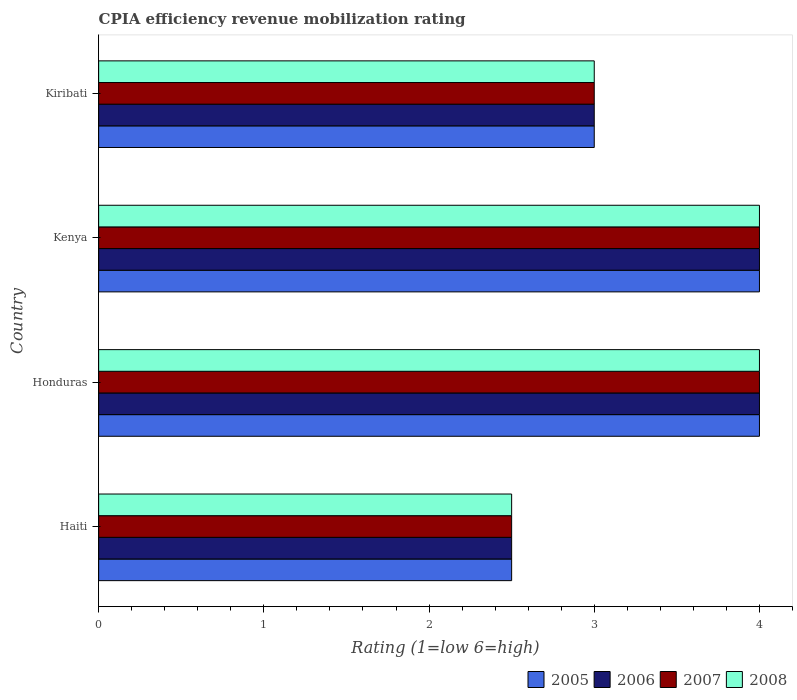How many different coloured bars are there?
Your answer should be compact. 4. Are the number of bars on each tick of the Y-axis equal?
Give a very brief answer. Yes. What is the label of the 1st group of bars from the top?
Provide a succinct answer. Kiribati. What is the CPIA rating in 2005 in Kenya?
Provide a short and direct response. 4. Across all countries, what is the maximum CPIA rating in 2007?
Offer a very short reply. 4. Across all countries, what is the minimum CPIA rating in 2006?
Your answer should be compact. 2.5. In which country was the CPIA rating in 2006 maximum?
Make the answer very short. Honduras. In which country was the CPIA rating in 2005 minimum?
Your response must be concise. Haiti. What is the total CPIA rating in 2007 in the graph?
Offer a very short reply. 13.5. What is the difference between the CPIA rating in 2005 in Haiti and that in Honduras?
Offer a very short reply. -1.5. What is the difference between the CPIA rating in 2008 in Kenya and the CPIA rating in 2005 in Honduras?
Keep it short and to the point. 0. What is the average CPIA rating in 2008 per country?
Make the answer very short. 3.38. What is the difference between the CPIA rating in 2005 and CPIA rating in 2006 in Kiribati?
Keep it short and to the point. 0. In how many countries, is the CPIA rating in 2006 greater than 1.8 ?
Provide a short and direct response. 4. What is the ratio of the CPIA rating in 2006 in Honduras to that in Kiribati?
Offer a very short reply. 1.33. Is the CPIA rating in 2008 in Haiti less than that in Honduras?
Provide a short and direct response. Yes. Is the sum of the CPIA rating in 2007 in Honduras and Kenya greater than the maximum CPIA rating in 2005 across all countries?
Offer a terse response. Yes. Is it the case that in every country, the sum of the CPIA rating in 2005 and CPIA rating in 2007 is greater than the sum of CPIA rating in 2006 and CPIA rating in 2008?
Ensure brevity in your answer.  No. Is it the case that in every country, the sum of the CPIA rating in 2005 and CPIA rating in 2007 is greater than the CPIA rating in 2006?
Make the answer very short. Yes. How many bars are there?
Your response must be concise. 16. How many countries are there in the graph?
Offer a very short reply. 4. Are the values on the major ticks of X-axis written in scientific E-notation?
Your answer should be compact. No. Does the graph contain any zero values?
Your answer should be very brief. No. Does the graph contain grids?
Provide a short and direct response. No. Where does the legend appear in the graph?
Offer a very short reply. Bottom right. How are the legend labels stacked?
Provide a succinct answer. Horizontal. What is the title of the graph?
Your answer should be compact. CPIA efficiency revenue mobilization rating. What is the label or title of the Y-axis?
Ensure brevity in your answer.  Country. What is the Rating (1=low 6=high) of 2005 in Haiti?
Provide a short and direct response. 2.5. What is the Rating (1=low 6=high) in 2006 in Haiti?
Ensure brevity in your answer.  2.5. What is the Rating (1=low 6=high) in 2007 in Haiti?
Your answer should be compact. 2.5. What is the Rating (1=low 6=high) of 2008 in Haiti?
Offer a terse response. 2.5. What is the Rating (1=low 6=high) of 2005 in Honduras?
Ensure brevity in your answer.  4. What is the Rating (1=low 6=high) of 2005 in Kenya?
Your answer should be very brief. 4. What is the Rating (1=low 6=high) in 2006 in Kiribati?
Your answer should be compact. 3. What is the Rating (1=low 6=high) in 2007 in Kiribati?
Give a very brief answer. 3. What is the Rating (1=low 6=high) in 2008 in Kiribati?
Give a very brief answer. 3. Across all countries, what is the maximum Rating (1=low 6=high) in 2006?
Keep it short and to the point. 4. Across all countries, what is the maximum Rating (1=low 6=high) of 2008?
Provide a succinct answer. 4. Across all countries, what is the minimum Rating (1=low 6=high) in 2006?
Keep it short and to the point. 2.5. Across all countries, what is the minimum Rating (1=low 6=high) in 2007?
Offer a terse response. 2.5. What is the total Rating (1=low 6=high) of 2005 in the graph?
Your response must be concise. 13.5. What is the total Rating (1=low 6=high) of 2008 in the graph?
Your answer should be very brief. 13.5. What is the difference between the Rating (1=low 6=high) of 2006 in Haiti and that in Honduras?
Make the answer very short. -1.5. What is the difference between the Rating (1=low 6=high) in 2005 in Haiti and that in Kenya?
Your response must be concise. -1.5. What is the difference between the Rating (1=low 6=high) in 2006 in Haiti and that in Kenya?
Offer a terse response. -1.5. What is the difference between the Rating (1=low 6=high) of 2007 in Haiti and that in Kenya?
Your answer should be compact. -1.5. What is the difference between the Rating (1=low 6=high) of 2005 in Honduras and that in Kiribati?
Provide a short and direct response. 1. What is the difference between the Rating (1=low 6=high) in 2006 in Honduras and that in Kiribati?
Offer a very short reply. 1. What is the difference between the Rating (1=low 6=high) of 2007 in Honduras and that in Kiribati?
Make the answer very short. 1. What is the difference between the Rating (1=low 6=high) of 2005 in Kenya and that in Kiribati?
Offer a very short reply. 1. What is the difference between the Rating (1=low 6=high) of 2006 in Haiti and the Rating (1=low 6=high) of 2007 in Honduras?
Offer a very short reply. -1.5. What is the difference between the Rating (1=low 6=high) of 2006 in Haiti and the Rating (1=low 6=high) of 2008 in Honduras?
Your response must be concise. -1.5. What is the difference between the Rating (1=low 6=high) in 2007 in Haiti and the Rating (1=low 6=high) in 2008 in Honduras?
Provide a short and direct response. -1.5. What is the difference between the Rating (1=low 6=high) of 2005 in Haiti and the Rating (1=low 6=high) of 2006 in Kenya?
Offer a very short reply. -1.5. What is the difference between the Rating (1=low 6=high) of 2005 in Haiti and the Rating (1=low 6=high) of 2007 in Kenya?
Your answer should be very brief. -1.5. What is the difference between the Rating (1=low 6=high) of 2006 in Haiti and the Rating (1=low 6=high) of 2007 in Kenya?
Your answer should be very brief. -1.5. What is the difference between the Rating (1=low 6=high) in 2005 in Haiti and the Rating (1=low 6=high) in 2006 in Kiribati?
Provide a succinct answer. -0.5. What is the difference between the Rating (1=low 6=high) of 2006 in Haiti and the Rating (1=low 6=high) of 2007 in Kiribati?
Your response must be concise. -0.5. What is the difference between the Rating (1=low 6=high) of 2005 in Honduras and the Rating (1=low 6=high) of 2006 in Kenya?
Provide a succinct answer. 0. What is the difference between the Rating (1=low 6=high) in 2007 in Honduras and the Rating (1=low 6=high) in 2008 in Kenya?
Provide a short and direct response. 0. What is the difference between the Rating (1=low 6=high) in 2005 in Honduras and the Rating (1=low 6=high) in 2006 in Kiribati?
Provide a short and direct response. 1. What is the difference between the Rating (1=low 6=high) in 2005 in Honduras and the Rating (1=low 6=high) in 2007 in Kiribati?
Your response must be concise. 1. What is the difference between the Rating (1=low 6=high) in 2006 in Honduras and the Rating (1=low 6=high) in 2007 in Kiribati?
Provide a short and direct response. 1. What is the difference between the Rating (1=low 6=high) of 2005 in Kenya and the Rating (1=low 6=high) of 2006 in Kiribati?
Ensure brevity in your answer.  1. What is the difference between the Rating (1=low 6=high) of 2005 in Kenya and the Rating (1=low 6=high) of 2008 in Kiribati?
Make the answer very short. 1. What is the difference between the Rating (1=low 6=high) in 2006 in Kenya and the Rating (1=low 6=high) in 2008 in Kiribati?
Offer a terse response. 1. What is the difference between the Rating (1=low 6=high) in 2007 in Kenya and the Rating (1=low 6=high) in 2008 in Kiribati?
Offer a terse response. 1. What is the average Rating (1=low 6=high) in 2005 per country?
Give a very brief answer. 3.38. What is the average Rating (1=low 6=high) in 2006 per country?
Keep it short and to the point. 3.38. What is the average Rating (1=low 6=high) in 2007 per country?
Offer a very short reply. 3.38. What is the average Rating (1=low 6=high) of 2008 per country?
Provide a short and direct response. 3.38. What is the difference between the Rating (1=low 6=high) of 2005 and Rating (1=low 6=high) of 2006 in Haiti?
Keep it short and to the point. 0. What is the difference between the Rating (1=low 6=high) in 2005 and Rating (1=low 6=high) in 2007 in Haiti?
Your response must be concise. 0. What is the difference between the Rating (1=low 6=high) in 2006 and Rating (1=low 6=high) in 2008 in Haiti?
Offer a very short reply. 0. What is the difference between the Rating (1=low 6=high) in 2005 and Rating (1=low 6=high) in 2006 in Honduras?
Provide a succinct answer. 0. What is the difference between the Rating (1=low 6=high) of 2005 and Rating (1=low 6=high) of 2007 in Honduras?
Make the answer very short. 0. What is the difference between the Rating (1=low 6=high) in 2005 and Rating (1=low 6=high) in 2006 in Kenya?
Ensure brevity in your answer.  0. What is the difference between the Rating (1=low 6=high) of 2005 and Rating (1=low 6=high) of 2007 in Kenya?
Your answer should be very brief. 0. What is the difference between the Rating (1=low 6=high) in 2005 and Rating (1=low 6=high) in 2008 in Kenya?
Your answer should be very brief. 0. What is the difference between the Rating (1=low 6=high) of 2006 and Rating (1=low 6=high) of 2007 in Kenya?
Provide a succinct answer. 0. What is the difference between the Rating (1=low 6=high) of 2005 and Rating (1=low 6=high) of 2007 in Kiribati?
Ensure brevity in your answer.  0. What is the difference between the Rating (1=low 6=high) of 2006 and Rating (1=low 6=high) of 2007 in Kiribati?
Make the answer very short. 0. What is the difference between the Rating (1=low 6=high) in 2006 and Rating (1=low 6=high) in 2008 in Kiribati?
Your answer should be very brief. 0. What is the difference between the Rating (1=low 6=high) of 2007 and Rating (1=low 6=high) of 2008 in Kiribati?
Your answer should be very brief. 0. What is the ratio of the Rating (1=low 6=high) of 2007 in Haiti to that in Honduras?
Offer a terse response. 0.62. What is the ratio of the Rating (1=low 6=high) in 2008 in Haiti to that in Honduras?
Ensure brevity in your answer.  0.62. What is the ratio of the Rating (1=low 6=high) in 2006 in Haiti to that in Kenya?
Ensure brevity in your answer.  0.62. What is the ratio of the Rating (1=low 6=high) of 2007 in Haiti to that in Kenya?
Provide a short and direct response. 0.62. What is the ratio of the Rating (1=low 6=high) of 2008 in Haiti to that in Kenya?
Your answer should be very brief. 0.62. What is the ratio of the Rating (1=low 6=high) in 2007 in Haiti to that in Kiribati?
Offer a very short reply. 0.83. What is the ratio of the Rating (1=low 6=high) of 2008 in Haiti to that in Kiribati?
Give a very brief answer. 0.83. What is the ratio of the Rating (1=low 6=high) in 2006 in Honduras to that in Kenya?
Ensure brevity in your answer.  1. What is the ratio of the Rating (1=low 6=high) of 2007 in Honduras to that in Kenya?
Your answer should be very brief. 1. What is the ratio of the Rating (1=low 6=high) in 2008 in Honduras to that in Kenya?
Provide a succinct answer. 1. What is the ratio of the Rating (1=low 6=high) in 2006 in Honduras to that in Kiribati?
Make the answer very short. 1.33. What is the ratio of the Rating (1=low 6=high) of 2007 in Honduras to that in Kiribati?
Provide a short and direct response. 1.33. What is the ratio of the Rating (1=low 6=high) of 2008 in Honduras to that in Kiribati?
Offer a terse response. 1.33. What is the ratio of the Rating (1=low 6=high) of 2005 in Kenya to that in Kiribati?
Offer a very short reply. 1.33. What is the difference between the highest and the second highest Rating (1=low 6=high) of 2006?
Your answer should be very brief. 0. What is the difference between the highest and the second highest Rating (1=low 6=high) of 2007?
Your answer should be very brief. 0. What is the difference between the highest and the second highest Rating (1=low 6=high) of 2008?
Your answer should be very brief. 0. What is the difference between the highest and the lowest Rating (1=low 6=high) of 2005?
Keep it short and to the point. 1.5. What is the difference between the highest and the lowest Rating (1=low 6=high) in 2008?
Offer a very short reply. 1.5. 